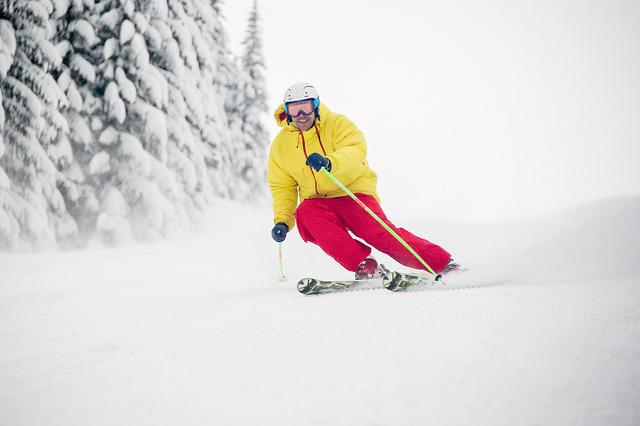What is this person doing?
Short answer required. Skiing. Is this a child?
Short answer required. No. Are the skiers going downhill?
Be succinct. Yes. Is the man wearing tight clothes?
Give a very brief answer. No. Is this photo colorful?
Concise answer only. Yes. What is written on the man's shirt?
Keep it brief. Nothing. What sport is depicted in this scene?
Write a very short answer. Skiing. Is this man going down a long slope?
Answer briefly. Yes. 